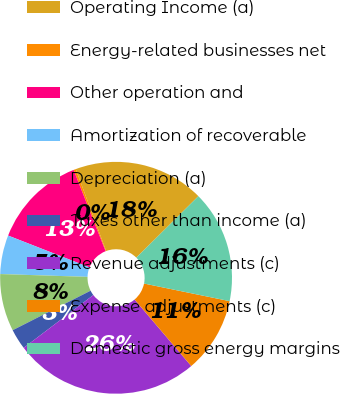Convert chart to OTSL. <chart><loc_0><loc_0><loc_500><loc_500><pie_chart><fcel>Operating Income (a)<fcel>Energy-related businesses net<fcel>Other operation and<fcel>Amortization of recoverable<fcel>Depreciation (a)<fcel>Taxes other than income (a)<fcel>Revenue adjustments (c)<fcel>Expense adjustments (c)<fcel>Domestic gross energy margins<nl><fcel>18.22%<fcel>0.31%<fcel>13.1%<fcel>5.42%<fcel>7.98%<fcel>2.86%<fcel>25.9%<fcel>10.54%<fcel>15.66%<nl></chart> 